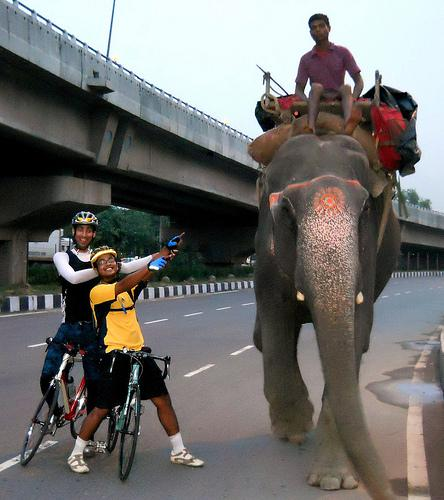Question: how many people are in the picture?
Choices:
A. Three.
B. Two.
C. Four.
D. Six.
Answer with the letter. Answer: A Question: how many people are on bicycles?
Choices:
A. Four.
B. One.
C. Two.
D. None.
Answer with the letter. Answer: C Question: how many freeway lanes are there?
Choices:
A. Three.
B. Two.
C. Four.
D. Six.
Answer with the letter. Answer: A Question: what kind of animal is in the picture?
Choices:
A. Dog.
B. Cat.
C. Ferret.
D. Elephant.
Answer with the letter. Answer: D 